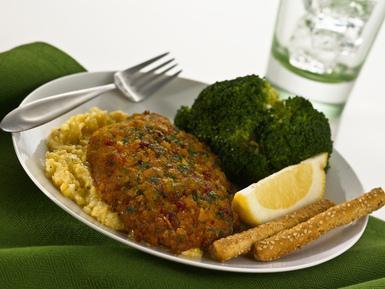Which item on the plate likely is highest in vitamins and minerals?
Make your selection and explain in format: 'Answer: answer
Rationale: rationale.'
Options: Grits, crab cake, lemon, broccoli. Answer: broccoli.
Rationale: Broccoli is very good for you. 